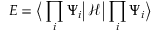Convert formula to latex. <formula><loc_0><loc_0><loc_500><loc_500>E = \left \langle \prod _ { i } \Psi _ { i } \left | \, \mathcal { H } \, \right | \prod _ { i } \Psi _ { i } \right \rangle</formula> 